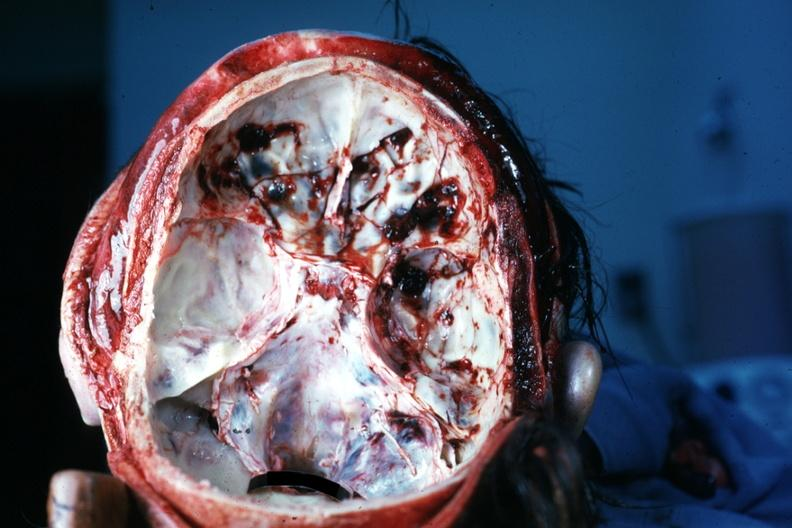does metastatic carcinoma show multiple fractures very good?
Answer the question using a single word or phrase. No 